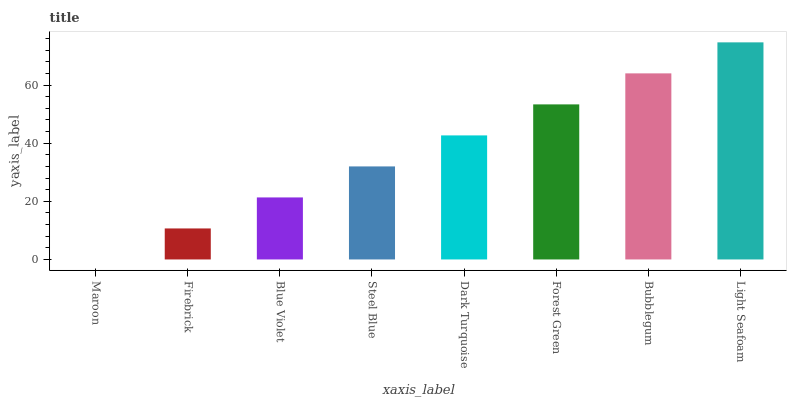Is Maroon the minimum?
Answer yes or no. Yes. Is Light Seafoam the maximum?
Answer yes or no. Yes. Is Firebrick the minimum?
Answer yes or no. No. Is Firebrick the maximum?
Answer yes or no. No. Is Firebrick greater than Maroon?
Answer yes or no. Yes. Is Maroon less than Firebrick?
Answer yes or no. Yes. Is Maroon greater than Firebrick?
Answer yes or no. No. Is Firebrick less than Maroon?
Answer yes or no. No. Is Dark Turquoise the high median?
Answer yes or no. Yes. Is Steel Blue the low median?
Answer yes or no. Yes. Is Forest Green the high median?
Answer yes or no. No. Is Bubblegum the low median?
Answer yes or no. No. 